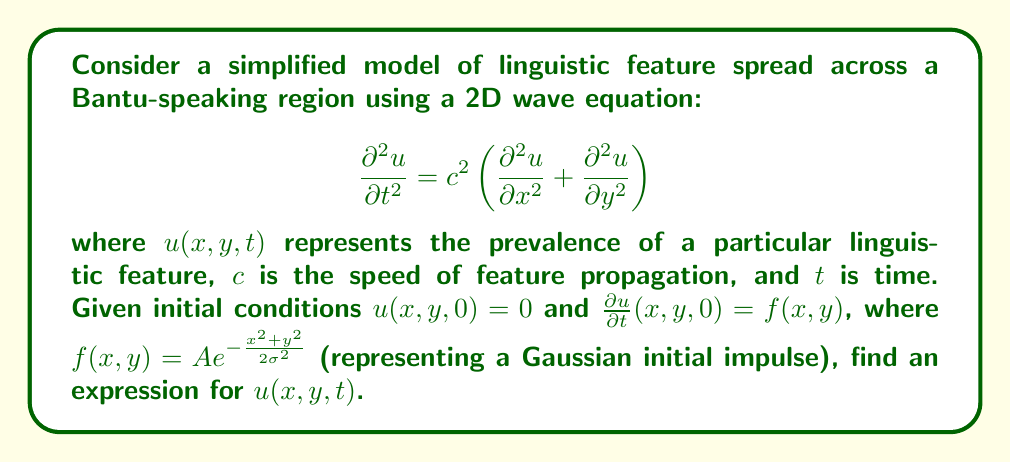Can you solve this math problem? To solve this problem, we'll use the method of separation of variables and Fourier transforms. The steps are as follows:

1) First, we apply a 2D Fourier transform to the wave equation:

   $$\frac{\partial^2 \hat{u}}{\partial t^2} = -c^2(k_x^2 + k_y^2)\hat{u}$$

   where $\hat{u}(k_x,k_y,t)$ is the Fourier transform of $u(x,y,t)$.

2) The general solution to this equation is:

   $$\hat{u}(k_x,k_y,t) = A(k_x,k_y)\cos(c\sqrt{k_x^2+k_y^2}t) + B(k_x,k_y)\sin(c\sqrt{k_x^2+k_y^2}t)$$

3) Using the initial conditions:

   $u(x,y,0) = 0$ implies $\hat{u}(k_x,k_y,0) = 0$, so $A(k_x,k_y) = 0$

   $\frac{\partial u}{\partial t}(x,y,0) = f(x,y)$ implies $\frac{\partial \hat{u}}{\partial t}(k_x,k_y,0) = \hat{f}(k_x,k_y)$

4) The Fourier transform of $f(x,y) = A e^{-\frac{x^2+y^2}{2\sigma^2}}$ is:

   $$\hat{f}(k_x,k_y) = 2\pi A\sigma^2 e^{-\frac{\sigma^2(k_x^2+k_y^2)}{2}}$$

5) From the derivative of $\hat{u}$ at $t=0$:

   $$B(k_x,k_y)c\sqrt{k_x^2+k_y^2} = 2\pi A\sigma^2 e^{-\frac{\sigma^2(k_x^2+k_y^2)}{2}}$$

6) Therefore:

   $$\hat{u}(k_x,k_y,t) = \frac{2\pi A\sigma^2}{c\sqrt{k_x^2+k_y^2}} e^{-\frac{\sigma^2(k_x^2+k_y^2)}{2}} \sin(c\sqrt{k_x^2+k_y^2}t)$$

7) To get $u(x,y,t)$, we need to take the inverse Fourier transform:

   $$u(x,y,t) = \frac{A}{2\pi c} \int_{-\infty}^{\infty}\int_{-\infty}^{\infty} \frac{\sigma^2}{\sqrt{k_x^2+k_y^2}} e^{-\frac{\sigma^2(k_x^2+k_y^2)}{2}} \sin(c\sqrt{k_x^2+k_y^2}t) e^{i(k_xx+k_yy)} dk_x dk_y$$

This integral can be simplified using polar coordinates, but the final closed-form solution involves Bessel functions and is quite complex.
Answer: The solution for $u(x,y,t)$ is:

$$u(x,y,t) = \frac{A}{2\pi c} \int_{-\infty}^{\infty}\int_{-\infty}^{\infty} \frac{\sigma^2}{\sqrt{k_x^2+k_y^2}} e^{-\frac{\sigma^2(k_x^2+k_y^2)}{2}} \sin(c\sqrt{k_x^2+k_y^2}t) e^{i(k_xx+k_yy)} dk_x dk_y$$ 